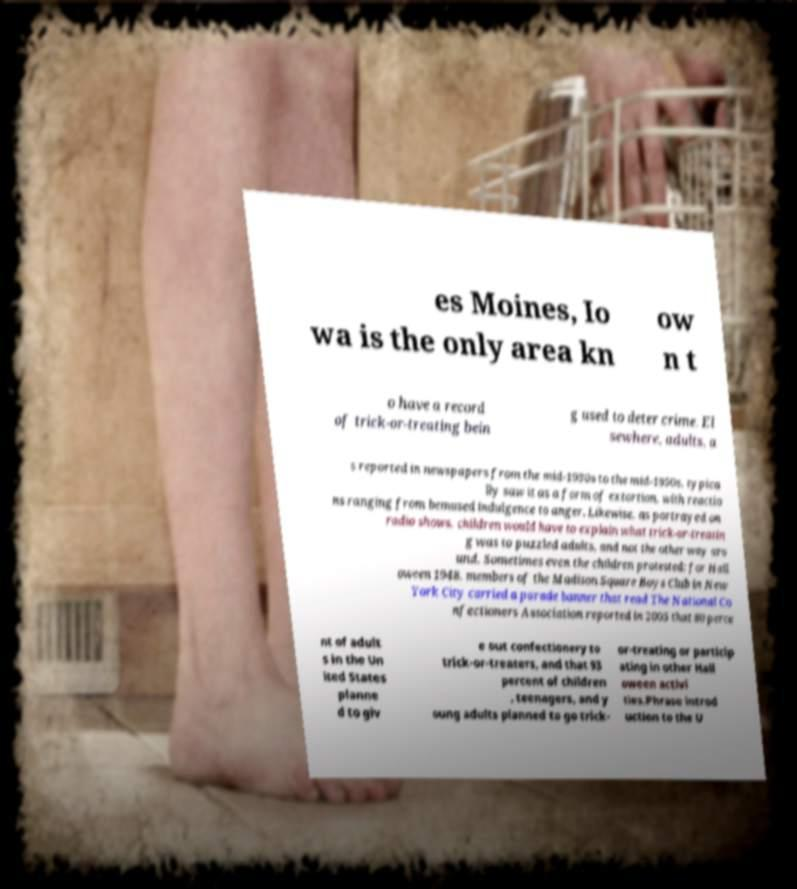Please read and relay the text visible in this image. What does it say? es Moines, Io wa is the only area kn ow n t o have a record of trick-or-treating bein g used to deter crime. El sewhere, adults, a s reported in newspapers from the mid-1930s to the mid-1950s, typica lly saw it as a form of extortion, with reactio ns ranging from bemused indulgence to anger. Likewise, as portrayed on radio shows, children would have to explain what trick-or-treatin g was to puzzled adults, and not the other way aro und. Sometimes even the children protested: for Hall oween 1948, members of the Madison Square Boys Club in New York City carried a parade banner that read The National Co nfectioners Association reported in 2005 that 80 perce nt of adult s in the Un ited States planne d to giv e out confectionery to trick-or-treaters, and that 93 percent of children , teenagers, and y oung adults planned to go trick- or-treating or particip ating in other Hall oween activi ties.Phrase introd uction to the U 